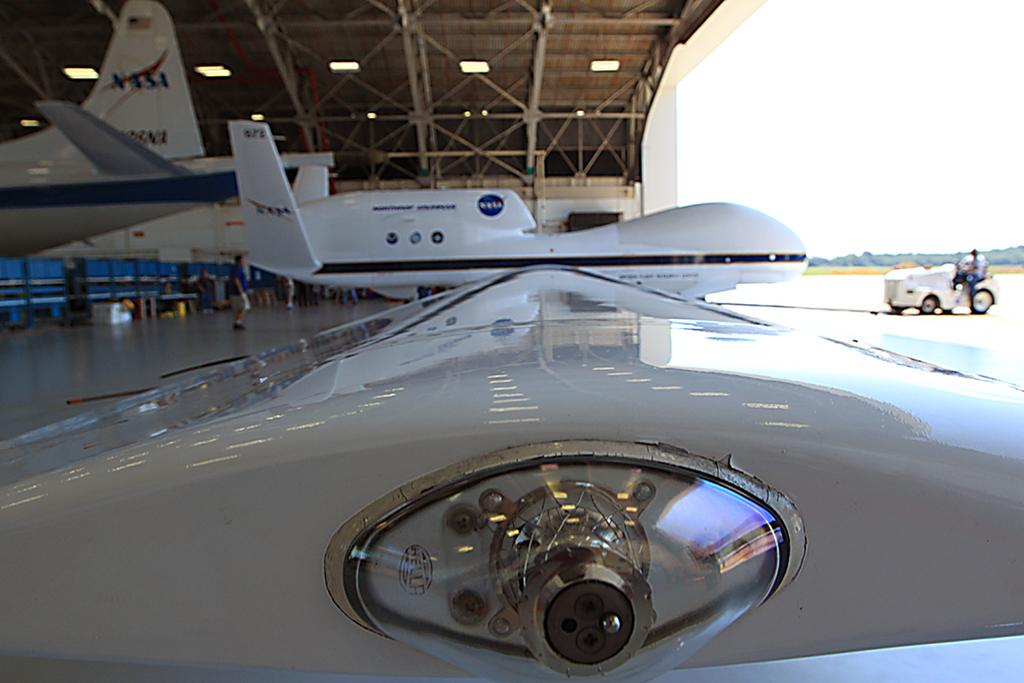<image>
Share a concise interpretation of the image provided. a plane with the word NASA written on the top 